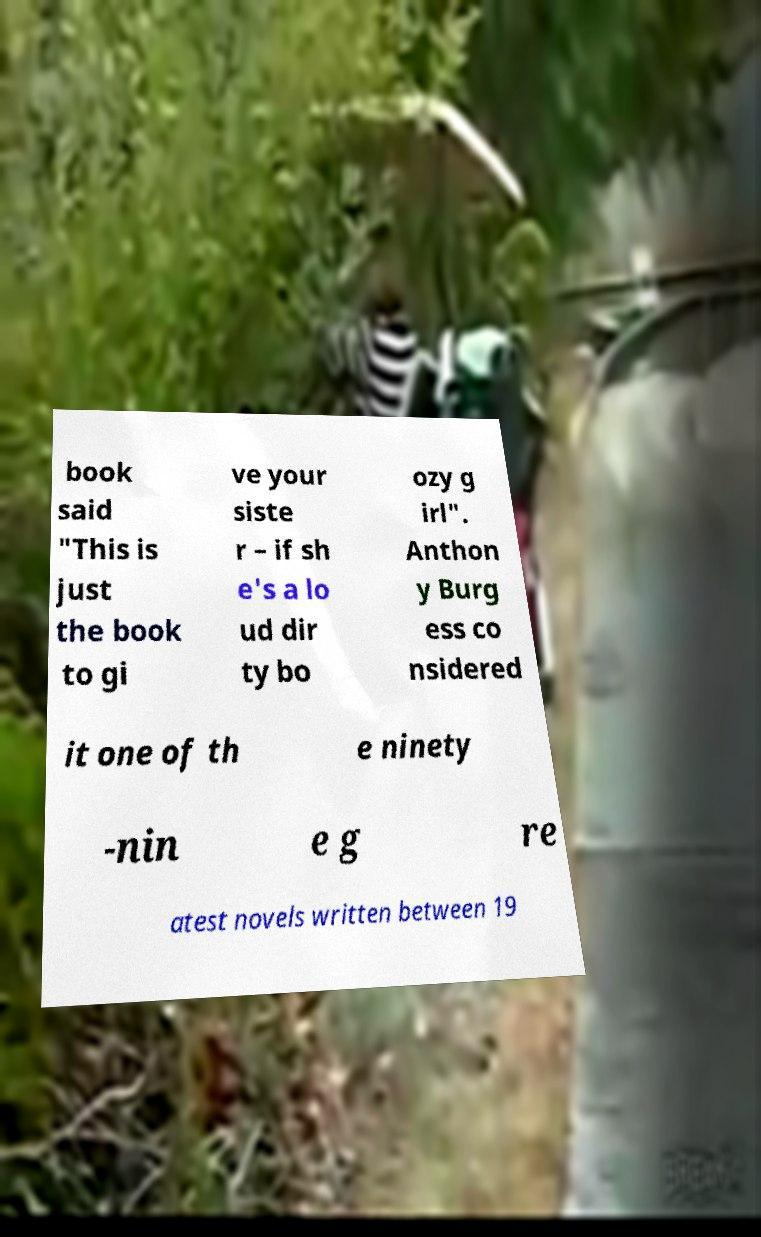There's text embedded in this image that I need extracted. Can you transcribe it verbatim? book said "This is just the book to gi ve your siste r – if sh e's a lo ud dir ty bo ozy g irl". Anthon y Burg ess co nsidered it one of th e ninety -nin e g re atest novels written between 19 